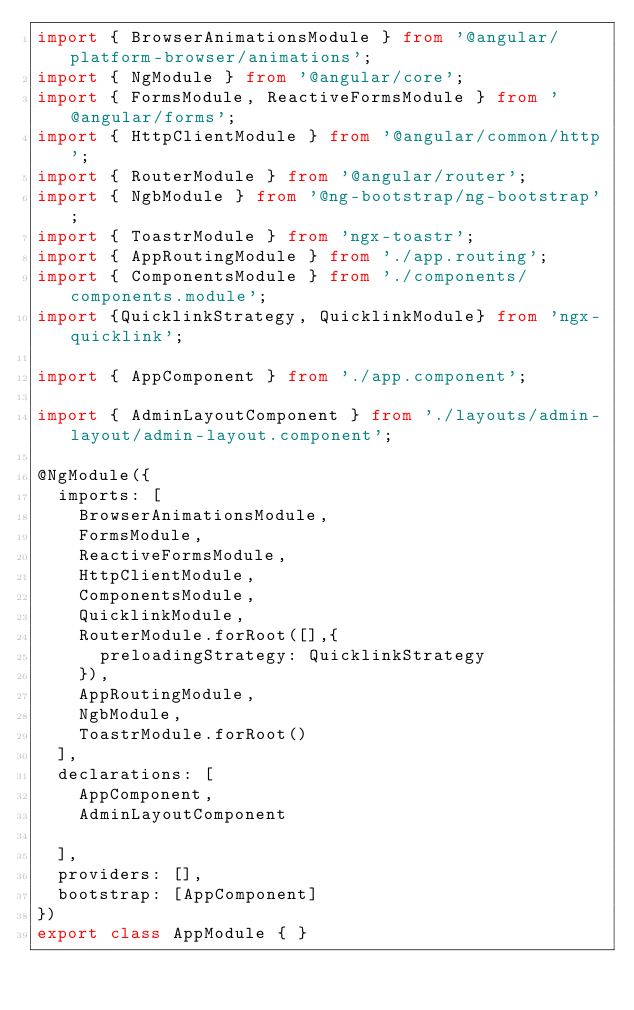Convert code to text. <code><loc_0><loc_0><loc_500><loc_500><_TypeScript_>import { BrowserAnimationsModule } from '@angular/platform-browser/animations';
import { NgModule } from '@angular/core';
import { FormsModule, ReactiveFormsModule } from '@angular/forms';
import { HttpClientModule } from '@angular/common/http';
import { RouterModule } from '@angular/router';
import { NgbModule } from '@ng-bootstrap/ng-bootstrap';
import { ToastrModule } from 'ngx-toastr';
import { AppRoutingModule } from './app.routing';
import { ComponentsModule } from './components/components.module';
import {QuicklinkStrategy, QuicklinkModule} from 'ngx-quicklink';

import { AppComponent } from './app.component';

import { AdminLayoutComponent } from './layouts/admin-layout/admin-layout.component';

@NgModule({
  imports: [
    BrowserAnimationsModule,
    FormsModule,
    ReactiveFormsModule,
    HttpClientModule,
    ComponentsModule,
    QuicklinkModule,
    RouterModule.forRoot([],{
      preloadingStrategy: QuicklinkStrategy
    }),
    AppRoutingModule,
    NgbModule,
    ToastrModule.forRoot()
  ],
  declarations: [
    AppComponent,
    AdminLayoutComponent

  ],
  providers: [],
  bootstrap: [AppComponent]
})
export class AppModule { }
</code> 